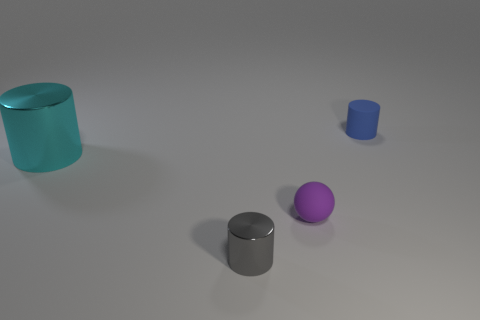Subtract all red cylinders. Subtract all cyan blocks. How many cylinders are left? 3 Add 2 tiny things. How many objects exist? 6 Subtract all spheres. How many objects are left? 3 Subtract all rubber cylinders. Subtract all cyan metal objects. How many objects are left? 2 Add 4 blue matte objects. How many blue matte objects are left? 5 Add 2 tiny purple objects. How many tiny purple objects exist? 3 Subtract 0 gray spheres. How many objects are left? 4 